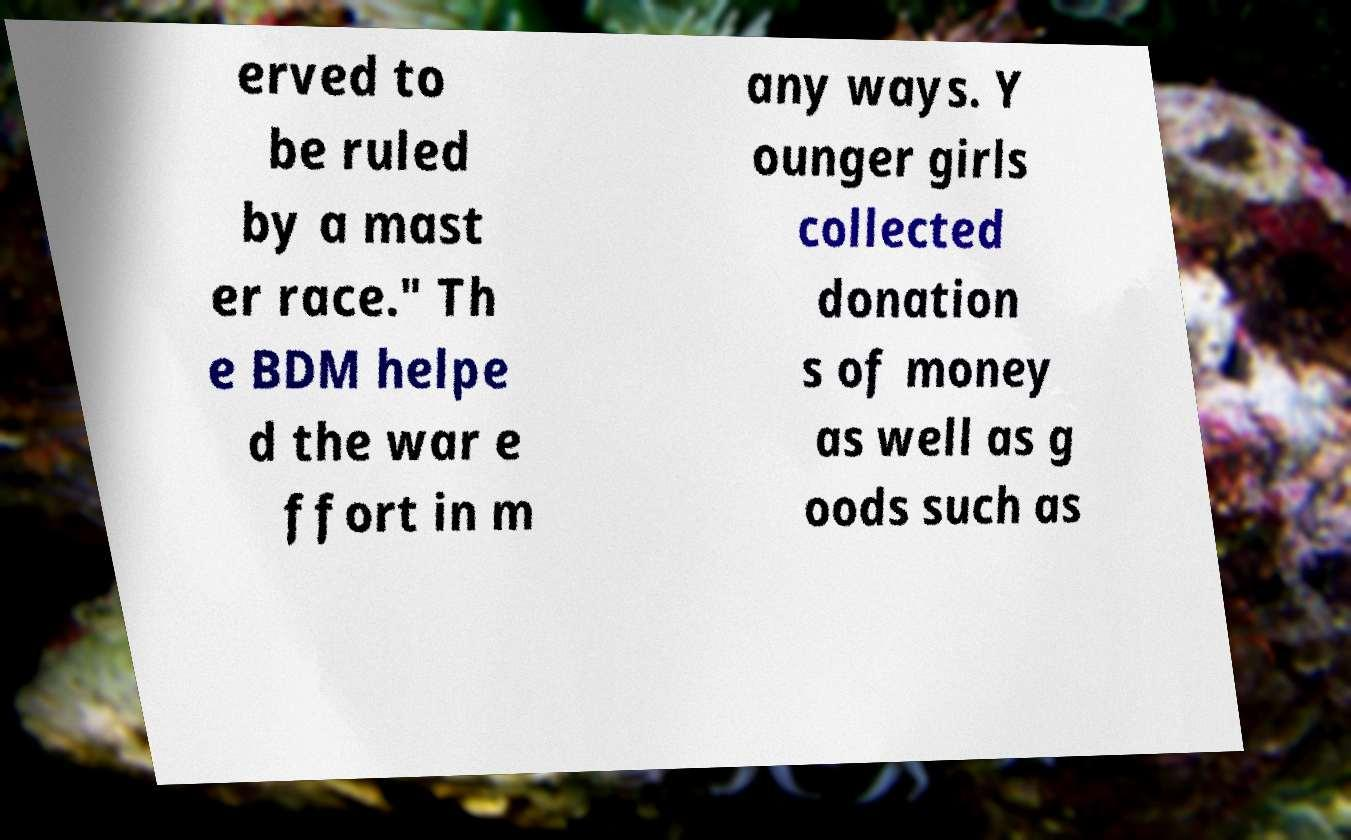I need the written content from this picture converted into text. Can you do that? erved to be ruled by a mast er race." Th e BDM helpe d the war e ffort in m any ways. Y ounger girls collected donation s of money as well as g oods such as 